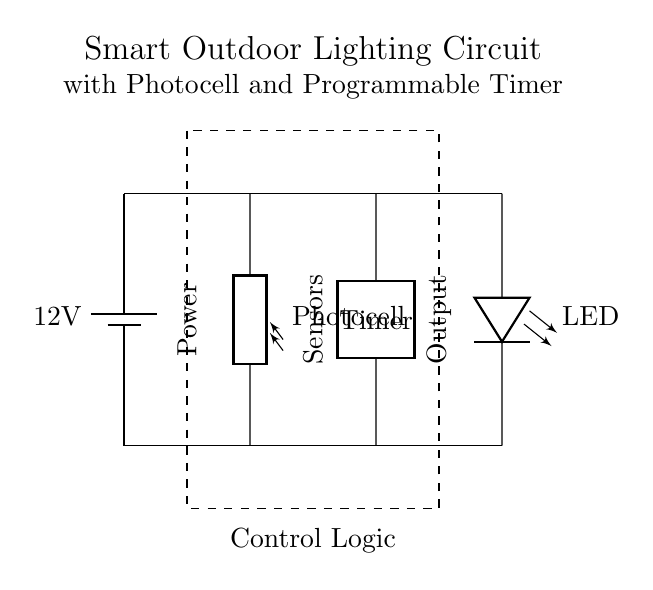What is the voltage supplied by the battery? The circuit shows a battery labeled with a voltage of 12 volts, which indicates the potential difference supplied to the components.
Answer: 12 volts What type of resistor is used in the circuit? The circuit includes a component labeled as a photocell, which is a type of photoresistor that changes resistance based on light levels.
Answer: Photocell How many main components are visible in this circuit? The circuit diagram includes four main components: the battery, photocell, programmable timer, and LED, leading to a total count of components.
Answer: Four What is the purpose of the programmable timer? The programmable timer is used to control the on and off times of the LED, allowing for scheduling based on user settings or specific needs.
Answer: Control lighting timing Which component detects light levels? The photocell in the circuit is responsible for detecting light levels, as it is designed to change its resistance based on the amount of ambient light present.
Answer: Photocell What does the dashed rectangle represent in the circuit? The dashed rectangle encloses the control logic section of the circuit, indicating that it contains the circuitry responsible for managing signals between components like the timer and the photocell.
Answer: Control logic 